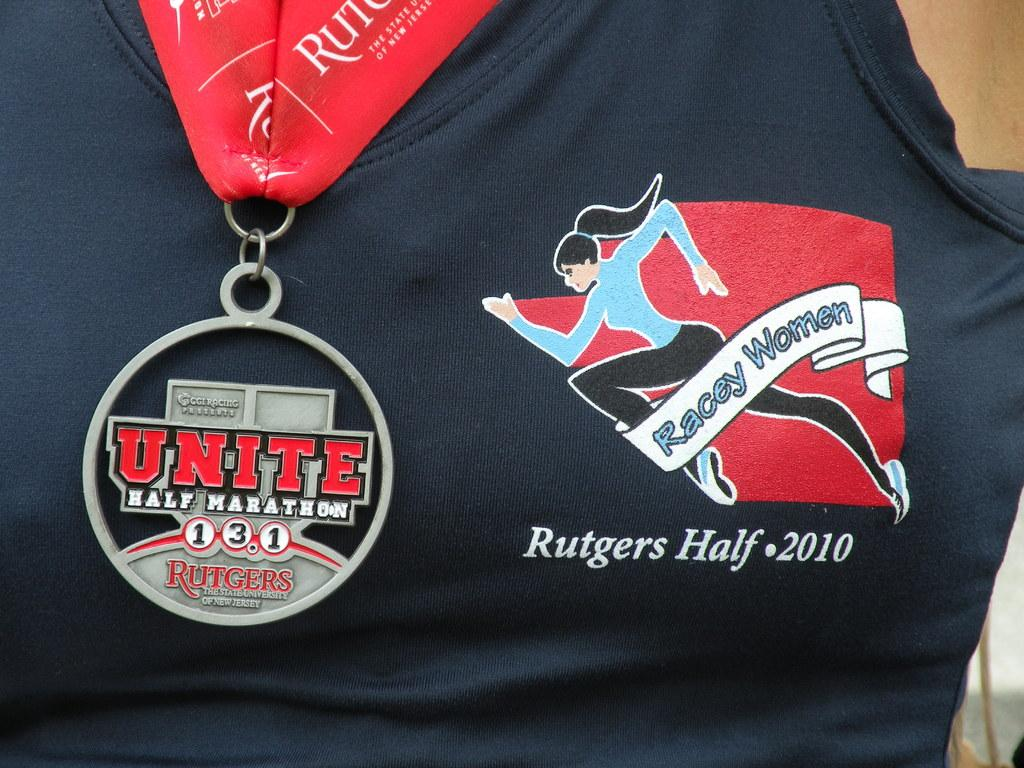<image>
Summarize the visual content of the image. Someone is wearing a medal for the Unite half marathon. 